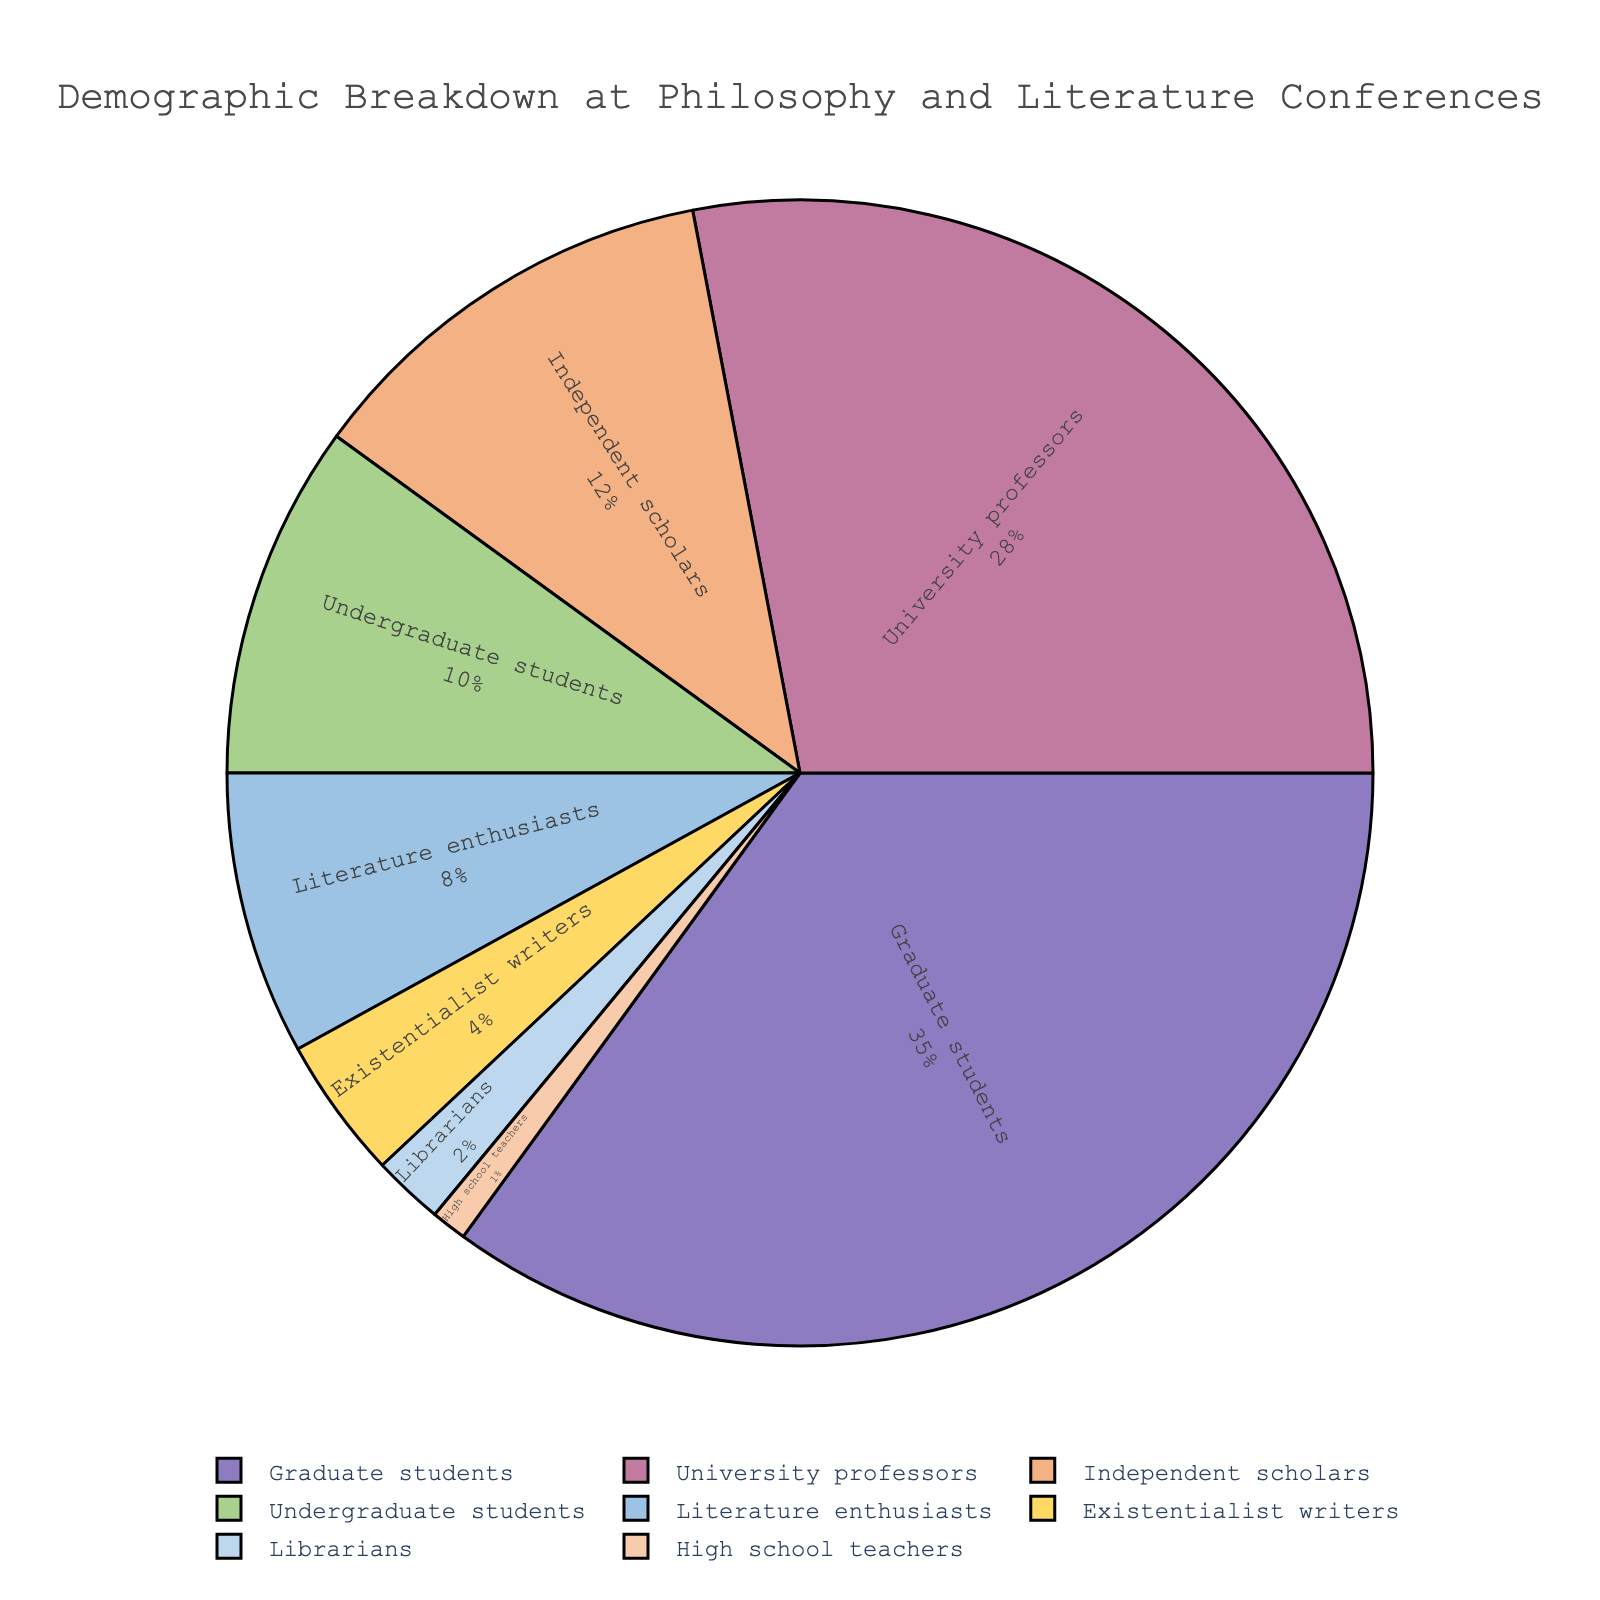Which category has the highest percentage of attendees? Identify the largest segment in the pie chart, which is labeled with both the category name and percentage. The largest segment is "Graduate students" marked with 35%.
Answer: Graduate students Which two categories together make up more than 50% of the attendees? Look for the two largest segments and add their percentages. "Graduate students" has 35%, and "University professors" has 28%. Together, they make 35% + 28% = 63%, which is over 50%.
Answer: Graduate students and University professors Which category has the smallest representation in the conference? Check the smallest segment of the pie chart. The smallest segment is labeled "High school teachers" with 1%.
Answer: High school teachers How many categories make up less than 10% of the attendees individually? Identify all segments with less than 10% and count them. Categories are "Independent scholars" (12%), "Undergraduate students" (10%), "Literature enthusiasts" (8%), "Existentialist writers" (4%), "Librarians" (2%), and "High school teachers" (1%), out of which the last four are less than 10%.
Answer: 4 What's the total percentage of attendees who are either Independent scholars or Literature enthusiasts? Add the percentages of "Independent scholars" and "Literature enthusiasts". Independent scholars have 12% and Literature enthusiasts have 8%. So, 12% + 8% = 20%.
Answer: 20% Which categories combined make up 50% or more of the attendees, but do not individually exceed that percentage? Find the groupings that sum up to 50% or more without any individual one exceeding 50%. Graduate students (35%) and University professors (28%) combined make 63%, meeting this criterion.
Answer: Graduate students and University professors If one more Existentialist writer attended, would their percentage exceed that of Librarians? Existentialist writers are currently at 4%, and Librarians are at 2%. Since 4% is already greater than 2%, adding one more Existentialist writer won't change this status.
Answer: Yes Which categories occupy the green and yellow segments of the pie chart? Observe the segments and identify the categories based on their colors. The green segment is "Undergraduate students" at 10% and the yellow segment is "Existentialist writers" at 4%.
Answer: Undergraduate students and Existentialist writers Is the category of Literature enthusiasts represented by a larger or smaller percentage than Undergraduate students? Compare their percentages directly from the chart. Literature enthusiasts have 8%, and Undergraduate students have 10%.
Answer: Smaller What is the combined percentage of categories that make up less than 5% each? Identify segments under 5%, which are "Existentialist writers" (4%) and "Librarians" (2%), and technically "High school teachers" (1%); sum them up. 4% + 2% + 1% = 7%.
Answer: 7% 